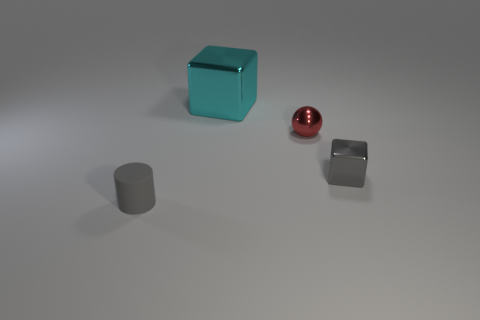Add 2 small balls. How many objects exist? 6 Subtract all cylinders. How many objects are left? 3 Subtract all tiny metal things. Subtract all cylinders. How many objects are left? 1 Add 1 small gray objects. How many small gray objects are left? 3 Add 1 big purple objects. How many big purple objects exist? 1 Subtract 0 brown cylinders. How many objects are left? 4 Subtract all yellow blocks. Subtract all blue balls. How many blocks are left? 2 